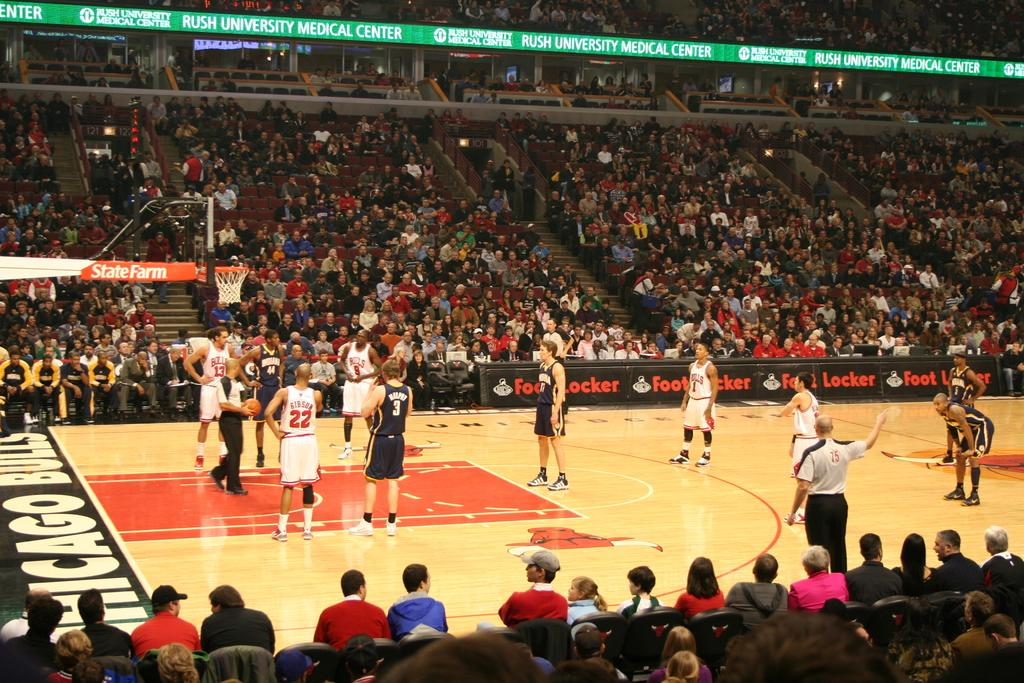What type of event is taking place in the image? The image shows a basketball game, as indicated by the presence of players, a basketball court, and a stadium. Who are the people in the image? There are people in the image who are likely to be the audience and players. What is the person holding in the image? The person is holding a ball, which is likely to be a basketball. What can be seen in the background of the image? There are hoardings visible in the image. How many legs does the afternoon have in the image? The concept of an afternoon having legs is not applicable in this context, as the image shows a basketball game. What type of base is supporting the stadium in the image? The image does not provide information about the base supporting the stadium; it only shows the stadium itself. 